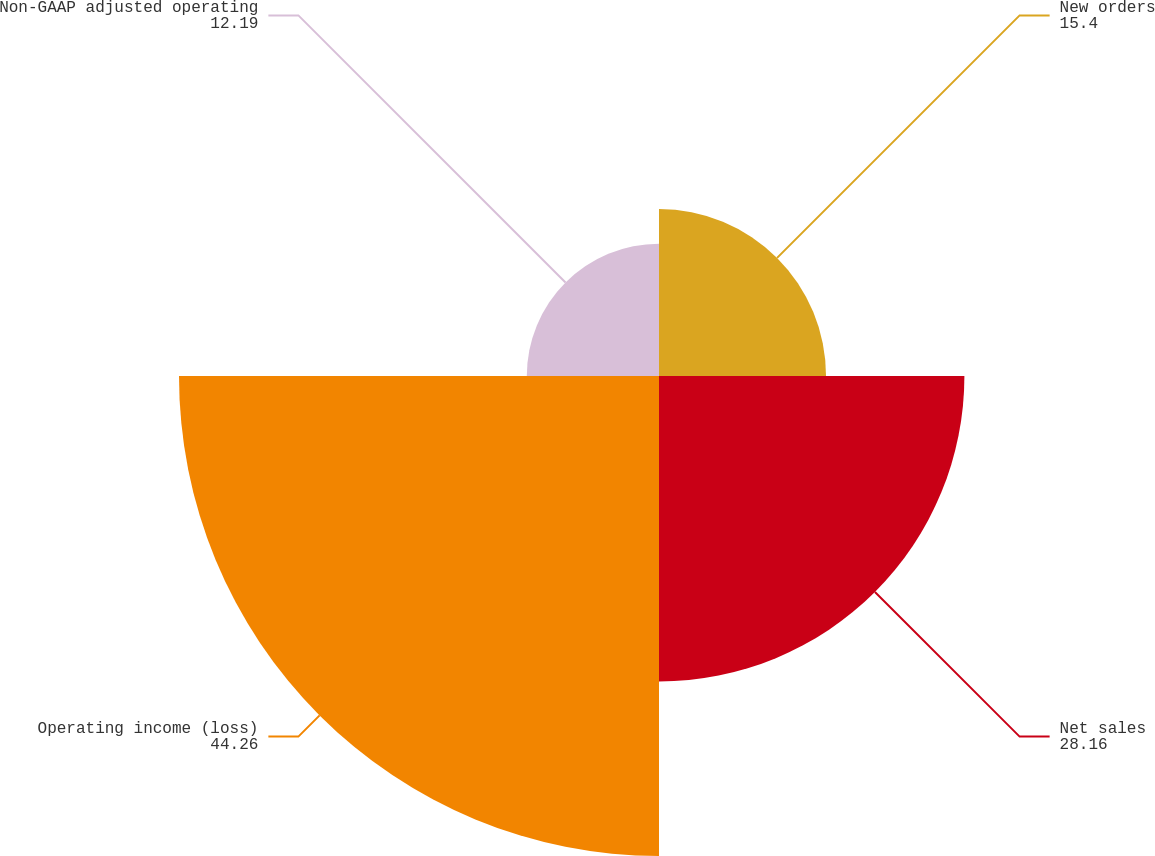Convert chart. <chart><loc_0><loc_0><loc_500><loc_500><pie_chart><fcel>New orders<fcel>Net sales<fcel>Operating income (loss)<fcel>Non-GAAP adjusted operating<nl><fcel>15.4%<fcel>28.16%<fcel>44.26%<fcel>12.19%<nl></chart> 